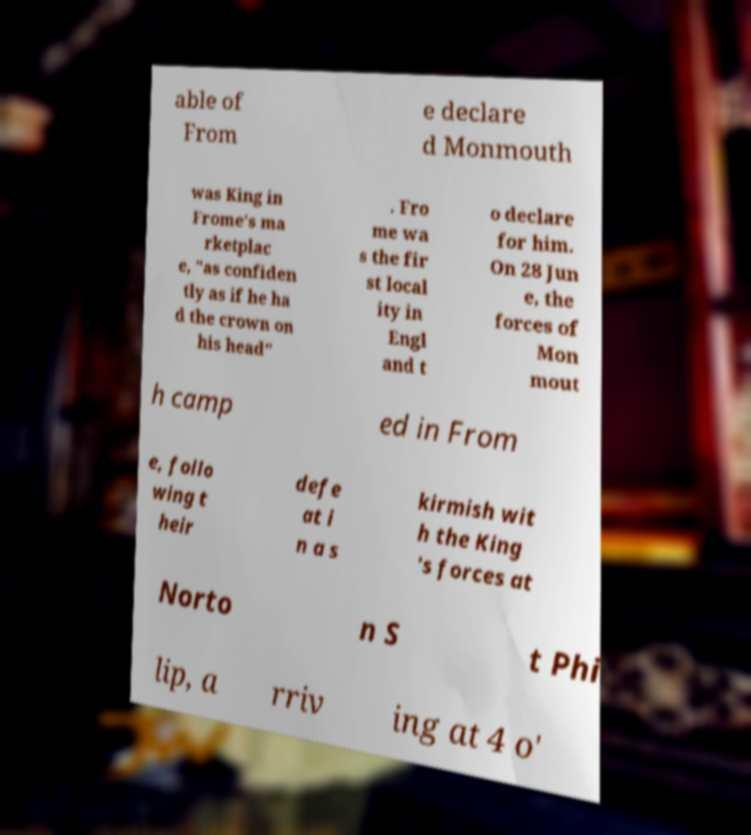Could you assist in decoding the text presented in this image and type it out clearly? able of From e declare d Monmouth was King in Frome's ma rketplac e, "as confiden tly as if he ha d the crown on his head" . Fro me wa s the fir st local ity in Engl and t o declare for him. On 28 Jun e, the forces of Mon mout h camp ed in From e, follo wing t heir defe at i n a s kirmish wit h the King 's forces at Norto n S t Phi lip, a rriv ing at 4 o' 